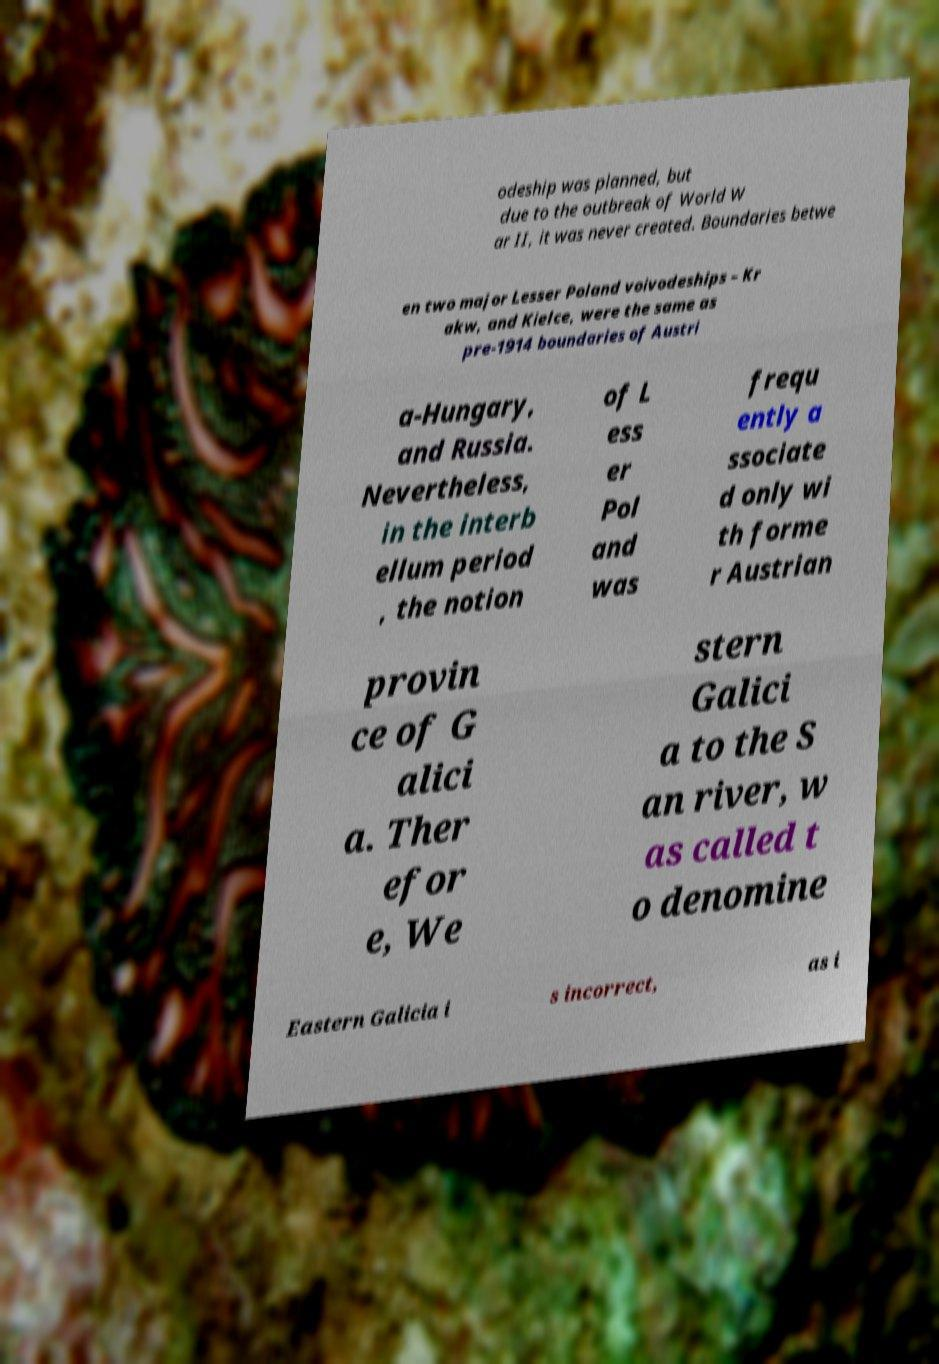Can you accurately transcribe the text from the provided image for me? odeship was planned, but due to the outbreak of World W ar II, it was never created. Boundaries betwe en two major Lesser Poland voivodeships – Kr akw, and Kielce, were the same as pre-1914 boundaries of Austri a-Hungary, and Russia. Nevertheless, in the interb ellum period , the notion of L ess er Pol and was frequ ently a ssociate d only wi th forme r Austrian provin ce of G alici a. Ther efor e, We stern Galici a to the S an river, w as called t o denomine Eastern Galicia i s incorrect, as i 